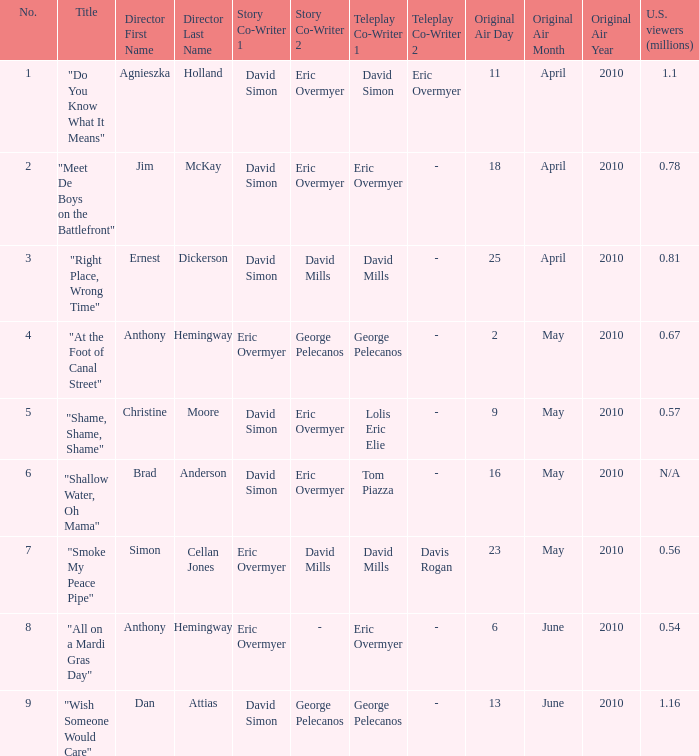Would you be able to parse every entry in this table? {'header': ['No.', 'Title', 'Director First Name', 'Director Last Name', 'Story Co-Writer 1', 'Story Co-Writer 2', 'Teleplay Co-Writer 1', 'Teleplay Co-Writer 2', 'Original Air Day', 'Original Air Month', 'Original Air Year', 'U.S. viewers (millions)'], 'rows': [['1', '"Do You Know What It Means"', 'Agnieszka', 'Holland', 'David Simon', 'Eric Overmyer', 'David Simon', 'Eric Overmyer', '11', 'April', '2010', '1.1'], ['2', '"Meet De Boys on the Battlefront"', 'Jim', 'McKay', 'David Simon', 'Eric Overmyer', 'Eric Overmyer', '-', '18', 'April', '2010', '0.78'], ['3', '"Right Place, Wrong Time"', 'Ernest', 'Dickerson', 'David Simon', 'David Mills', 'David Mills', '-', '25', 'April', '2010', '0.81'], ['4', '"At the Foot of Canal Street"', 'Anthony', 'Hemingway', 'Eric Overmyer', 'George Pelecanos', 'George Pelecanos', '-', '2', 'May', '2010', '0.67'], ['5', '"Shame, Shame, Shame"', 'Christine', 'Moore', 'David Simon', 'Eric Overmyer', 'Lolis Eric Elie', '-', '9', 'May', '2010', '0.57'], ['6', '"Shallow Water, Oh Mama"', 'Brad', 'Anderson', 'David Simon', 'Eric Overmyer', 'Tom Piazza', '-', '16', 'May', '2010', 'N/A'], ['7', '"Smoke My Peace Pipe"', 'Simon', 'Cellan Jones', 'Eric Overmyer', 'David Mills', 'David Mills', 'Davis Rogan', '23', 'May', '2010', '0.56'], ['8', '"All on a Mardi Gras Day"', 'Anthony', 'Hemingway', 'Eric Overmyer', '-', 'Eric Overmyer', '-', '6', 'June', '2010', '0.54'], ['9', '"Wish Someone Would Care"', 'Dan', 'Attias', 'David Simon', 'George Pelecanos', 'George Pelecanos', '-', '13', 'June', '2010', '1.16']]} Name the us viewers directed by christine moore 0.57. 